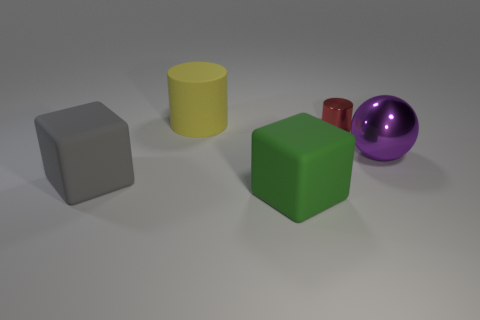Add 3 large gray rubber objects. How many objects exist? 8 Subtract all spheres. How many objects are left? 4 Add 1 big yellow matte cylinders. How many big yellow matte cylinders are left? 2 Add 4 small red shiny cylinders. How many small red shiny cylinders exist? 5 Subtract 0 blue cubes. How many objects are left? 5 Subtract all big blue balls. Subtract all red cylinders. How many objects are left? 4 